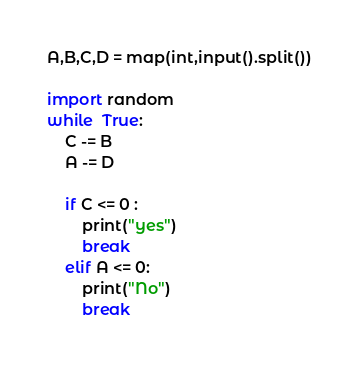<code> <loc_0><loc_0><loc_500><loc_500><_Python_>A,B,C,D = map(int,input().split())

import random
while  True:
    C -= B
    A -= D

    if C <= 0 :
        print("yes")
        break
    elif A <= 0:
        print("No")
        break
</code> 